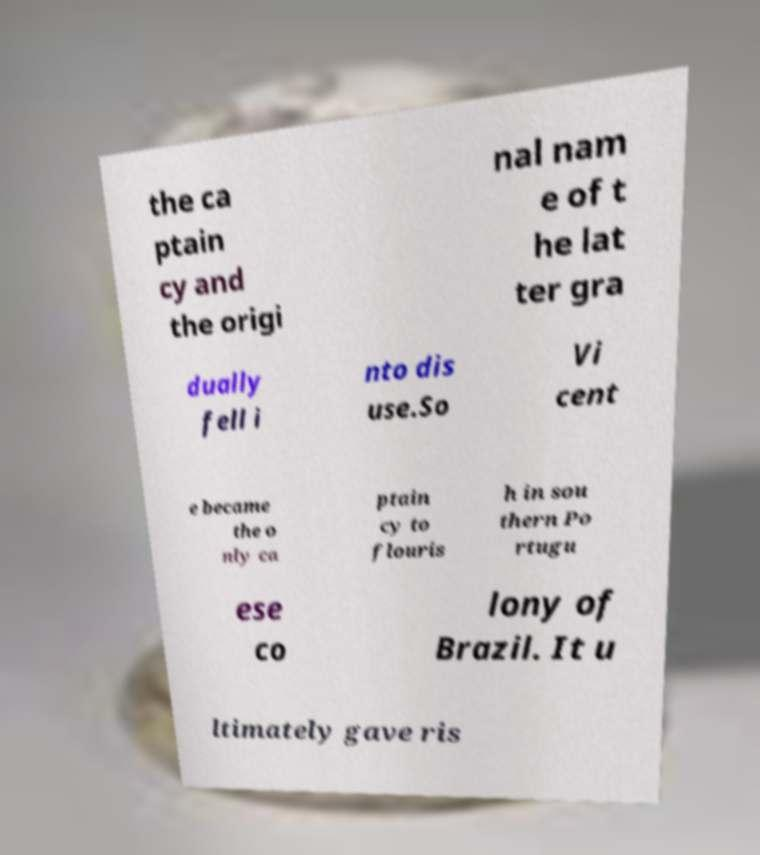Can you read and provide the text displayed in the image?This photo seems to have some interesting text. Can you extract and type it out for me? the ca ptain cy and the origi nal nam e of t he lat ter gra dually fell i nto dis use.So Vi cent e became the o nly ca ptain cy to flouris h in sou thern Po rtugu ese co lony of Brazil. It u ltimately gave ris 